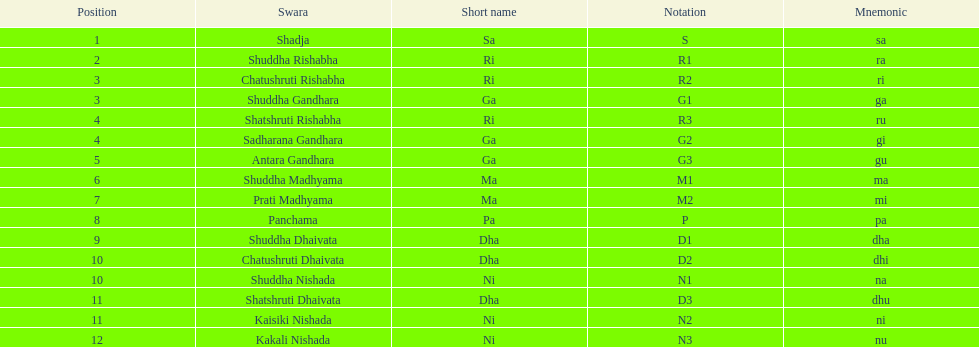Would you be able to parse every entry in this table? {'header': ['Position', 'Swara', 'Short name', 'Notation', 'Mnemonic'], 'rows': [['1', 'Shadja', 'Sa', 'S', 'sa'], ['2', 'Shuddha Rishabha', 'Ri', 'R1', 'ra'], ['3', 'Chatushruti Rishabha', 'Ri', 'R2', 'ri'], ['3', 'Shuddha Gandhara', 'Ga', 'G1', 'ga'], ['4', 'Shatshruti Rishabha', 'Ri', 'R3', 'ru'], ['4', 'Sadharana Gandhara', 'Ga', 'G2', 'gi'], ['5', 'Antara Gandhara', 'Ga', 'G3', 'gu'], ['6', 'Shuddha Madhyama', 'Ma', 'M1', 'ma'], ['7', 'Prati Madhyama', 'Ma', 'M2', 'mi'], ['8', 'Panchama', 'Pa', 'P', 'pa'], ['9', 'Shuddha Dhaivata', 'Dha', 'D1', 'dha'], ['10', 'Chatushruti Dhaivata', 'Dha', 'D2', 'dhi'], ['10', 'Shuddha Nishada', 'Ni', 'N1', 'na'], ['11', 'Shatshruti Dhaivata', 'Dha', 'D3', 'dhu'], ['11', 'Kaisiki Nishada', 'Ni', 'N2', 'ni'], ['12', 'Kakali Nishada', 'Ni', 'N3', 'nu']]} What's the sum of all listed positions? 16. 